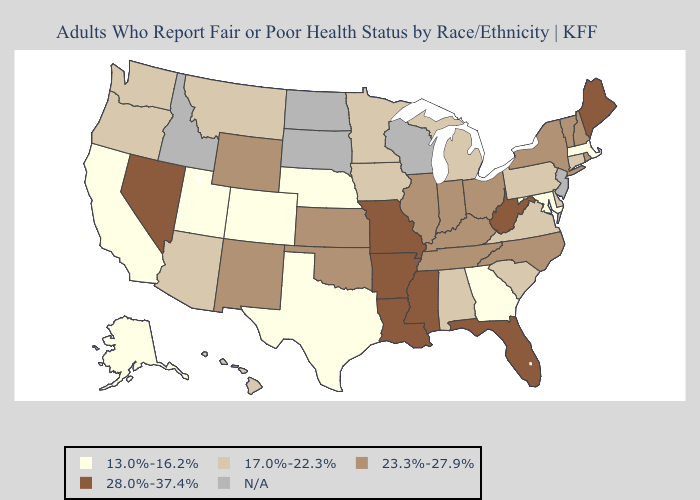Does Utah have the highest value in the USA?
Give a very brief answer. No. What is the lowest value in the Northeast?
Give a very brief answer. 13.0%-16.2%. Does the first symbol in the legend represent the smallest category?
Be succinct. Yes. Which states have the lowest value in the USA?
Quick response, please. Alaska, California, Colorado, Georgia, Maryland, Massachusetts, Nebraska, Texas, Utah. What is the value of Illinois?
Be succinct. 23.3%-27.9%. Does Arkansas have the highest value in the USA?
Quick response, please. Yes. What is the value of Pennsylvania?
Keep it brief. 17.0%-22.3%. What is the value of Alaska?
Keep it brief. 13.0%-16.2%. Name the states that have a value in the range 23.3%-27.9%?
Keep it brief. Illinois, Indiana, Kansas, Kentucky, New Hampshire, New Mexico, New York, North Carolina, Ohio, Oklahoma, Rhode Island, Tennessee, Vermont, Wyoming. How many symbols are there in the legend?
Be succinct. 5. Does the map have missing data?
Write a very short answer. Yes. Does the map have missing data?
Be succinct. Yes. 